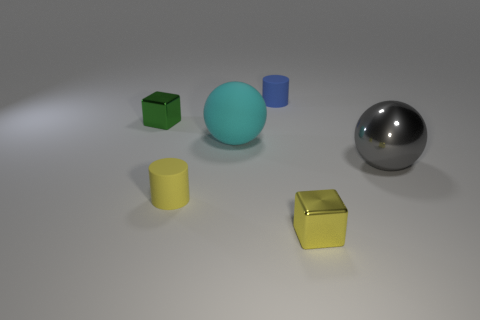Add 2 red rubber objects. How many objects exist? 8 Subtract all cylinders. How many objects are left? 4 Add 2 yellow shiny things. How many yellow shiny things exist? 3 Subtract 0 brown cylinders. How many objects are left? 6 Subtract all small yellow things. Subtract all tiny yellow metal balls. How many objects are left? 4 Add 1 tiny yellow matte cylinders. How many tiny yellow matte cylinders are left? 2 